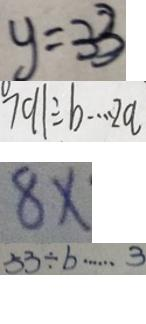Convert formula to latex. <formula><loc_0><loc_0><loc_500><loc_500>y = 3 3 
 7 9 1 \div b \cdots 2 a 
 8 x 
 5 3 \div b \cdots 3</formula> 